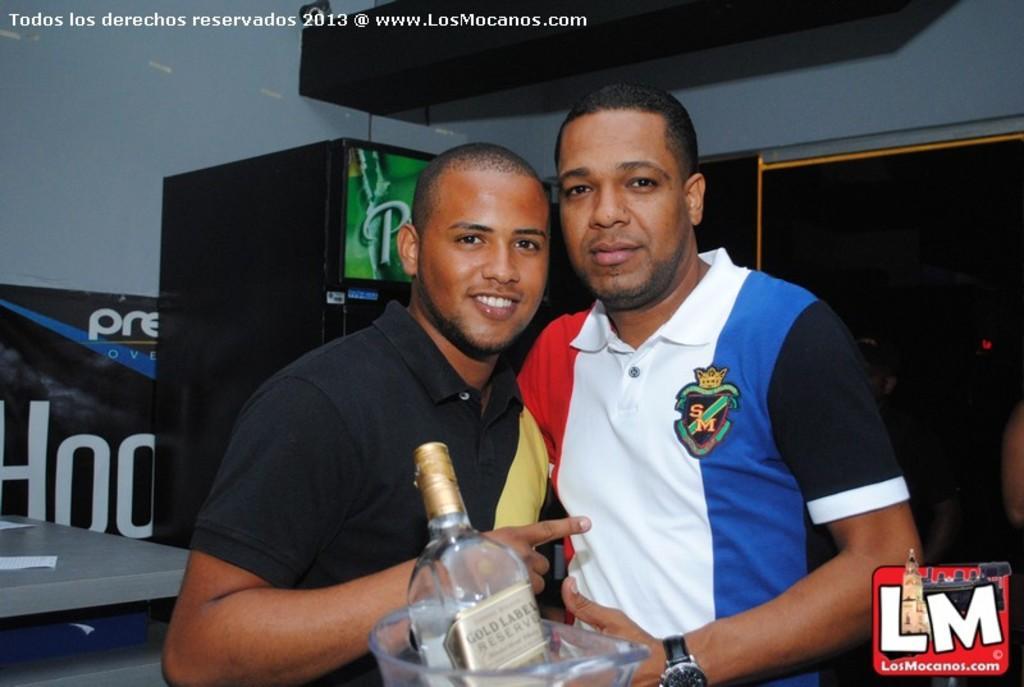In one or two sentences, can you explain what this image depicts? There are two men standing together holding a jar with bottle in it. 